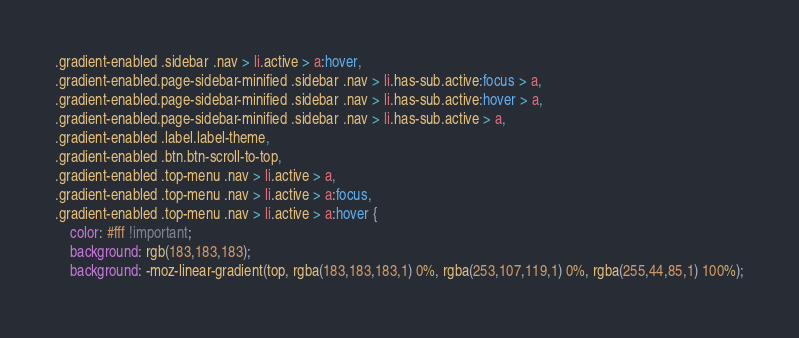<code> <loc_0><loc_0><loc_500><loc_500><_CSS_>.gradient-enabled .sidebar .nav > li.active > a:hover,
.gradient-enabled.page-sidebar-minified .sidebar .nav > li.has-sub.active:focus > a, 
.gradient-enabled.page-sidebar-minified .sidebar .nav > li.has-sub.active:hover > a, 
.gradient-enabled.page-sidebar-minified .sidebar .nav > li.has-sub.active > a,
.gradient-enabled .label.label-theme,
.gradient-enabled .btn.btn-scroll-to-top,
.gradient-enabled .top-menu .nav > li.active > a, 
.gradient-enabled .top-menu .nav > li.active > a:focus, 
.gradient-enabled .top-menu .nav > li.active > a:hover { 
	color: #fff !important;
	background: rgb(183,183,183);
	background: -moz-linear-gradient(top, rgba(183,183,183,1) 0%, rgba(253,107,119,1) 0%, rgba(255,44,85,1) 100%);</code> 